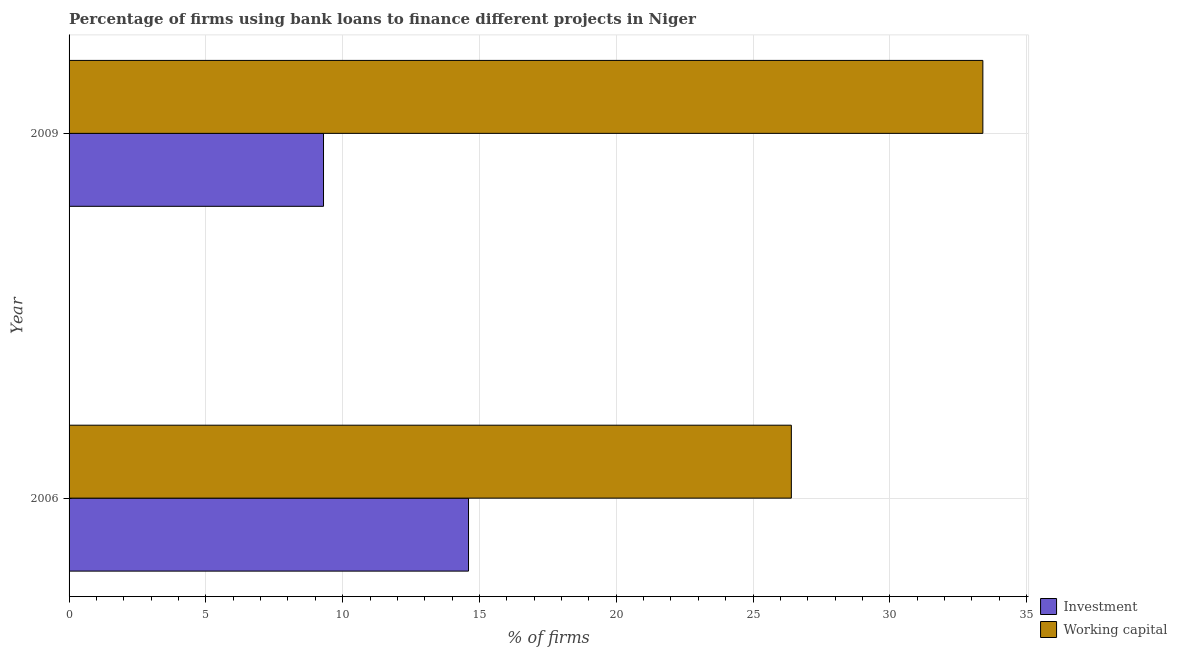How many different coloured bars are there?
Give a very brief answer. 2. Are the number of bars per tick equal to the number of legend labels?
Give a very brief answer. Yes. How many bars are there on the 1st tick from the top?
Give a very brief answer. 2. How many bars are there on the 1st tick from the bottom?
Your response must be concise. 2. What is the percentage of firms using banks to finance working capital in 2006?
Ensure brevity in your answer.  26.4. Across all years, what is the maximum percentage of firms using banks to finance working capital?
Give a very brief answer. 33.4. Across all years, what is the minimum percentage of firms using banks to finance investment?
Ensure brevity in your answer.  9.3. In which year was the percentage of firms using banks to finance investment maximum?
Give a very brief answer. 2006. In which year was the percentage of firms using banks to finance investment minimum?
Provide a short and direct response. 2009. What is the total percentage of firms using banks to finance working capital in the graph?
Give a very brief answer. 59.8. What is the difference between the percentage of firms using banks to finance investment in 2009 and the percentage of firms using banks to finance working capital in 2006?
Provide a succinct answer. -17.1. What is the average percentage of firms using banks to finance working capital per year?
Your response must be concise. 29.9. In the year 2009, what is the difference between the percentage of firms using banks to finance investment and percentage of firms using banks to finance working capital?
Provide a succinct answer. -24.1. In how many years, is the percentage of firms using banks to finance investment greater than 10 %?
Your answer should be compact. 1. What is the ratio of the percentage of firms using banks to finance investment in 2006 to that in 2009?
Provide a succinct answer. 1.57. In how many years, is the percentage of firms using banks to finance working capital greater than the average percentage of firms using banks to finance working capital taken over all years?
Ensure brevity in your answer.  1. What does the 2nd bar from the top in 2009 represents?
Make the answer very short. Investment. What does the 1st bar from the bottom in 2006 represents?
Offer a terse response. Investment. How many bars are there?
Ensure brevity in your answer.  4. How many years are there in the graph?
Offer a terse response. 2. What is the difference between two consecutive major ticks on the X-axis?
Your answer should be very brief. 5. Does the graph contain grids?
Offer a terse response. Yes. Where does the legend appear in the graph?
Keep it short and to the point. Bottom right. How are the legend labels stacked?
Keep it short and to the point. Vertical. What is the title of the graph?
Your answer should be compact. Percentage of firms using bank loans to finance different projects in Niger. What is the label or title of the X-axis?
Your answer should be compact. % of firms. What is the % of firms of Working capital in 2006?
Offer a very short reply. 26.4. What is the % of firms of Working capital in 2009?
Ensure brevity in your answer.  33.4. Across all years, what is the maximum % of firms of Working capital?
Offer a very short reply. 33.4. Across all years, what is the minimum % of firms of Working capital?
Make the answer very short. 26.4. What is the total % of firms of Investment in the graph?
Your answer should be compact. 23.9. What is the total % of firms in Working capital in the graph?
Keep it short and to the point. 59.8. What is the difference between the % of firms in Investment in 2006 and that in 2009?
Offer a terse response. 5.3. What is the difference between the % of firms of Investment in 2006 and the % of firms of Working capital in 2009?
Provide a succinct answer. -18.8. What is the average % of firms of Investment per year?
Offer a terse response. 11.95. What is the average % of firms of Working capital per year?
Provide a succinct answer. 29.9. In the year 2009, what is the difference between the % of firms of Investment and % of firms of Working capital?
Your answer should be very brief. -24.1. What is the ratio of the % of firms of Investment in 2006 to that in 2009?
Your answer should be very brief. 1.57. What is the ratio of the % of firms of Working capital in 2006 to that in 2009?
Your answer should be compact. 0.79. What is the difference between the highest and the second highest % of firms of Investment?
Your answer should be very brief. 5.3. What is the difference between the highest and the second highest % of firms of Working capital?
Keep it short and to the point. 7. What is the difference between the highest and the lowest % of firms of Investment?
Provide a short and direct response. 5.3. 